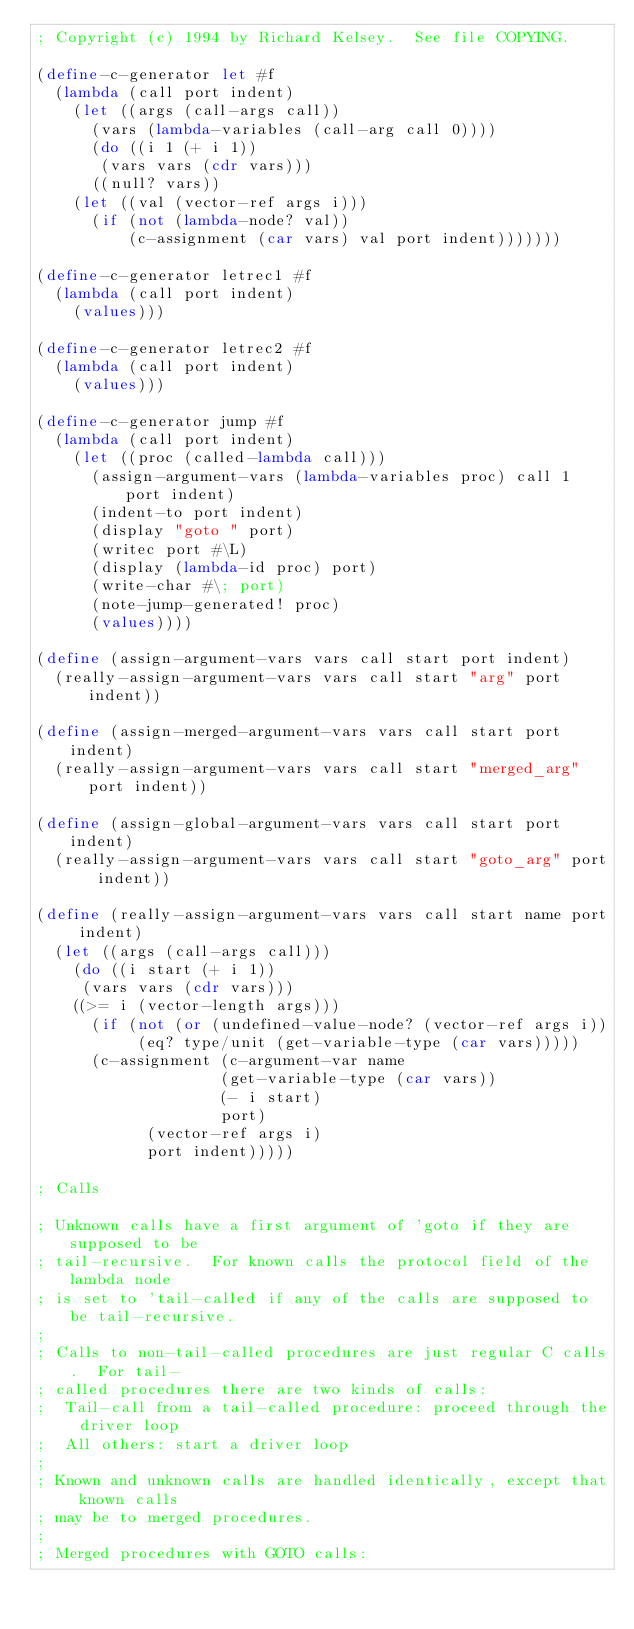Convert code to text. <code><loc_0><loc_0><loc_500><loc_500><_Scheme_>; Copyright (c) 1994 by Richard Kelsey.  See file COPYING.

(define-c-generator let #f
  (lambda (call port indent)
    (let ((args (call-args call))
	  (vars (lambda-variables (call-arg call 0))))
      (do ((i 1 (+ i 1))
	   (vars vars (cdr vars)))
	  ((null? vars))
	(let ((val (vector-ref args i)))
	  (if (not (lambda-node? val))
	      (c-assignment (car vars) val port indent)))))))

(define-c-generator letrec1 #f
  (lambda (call port indent)
    (values)))

(define-c-generator letrec2 #f
  (lambda (call port indent)
    (values)))

(define-c-generator jump #f
  (lambda (call port indent)
    (let ((proc (called-lambda call)))
      (assign-argument-vars (lambda-variables proc) call 1 port indent)
      (indent-to port indent)
      (display "goto " port)
      (writec port #\L)
      (display (lambda-id proc) port)
      (write-char #\; port)
      (note-jump-generated! proc)
      (values))))
  
(define (assign-argument-vars vars call start port indent)
  (really-assign-argument-vars vars call start "arg" port indent))

(define (assign-merged-argument-vars vars call start port indent)
  (really-assign-argument-vars vars call start "merged_arg" port indent))

(define (assign-global-argument-vars vars call start port indent)
  (really-assign-argument-vars vars call start "goto_arg" port indent))

(define (really-assign-argument-vars vars call start name port indent)
  (let ((args (call-args call)))
    (do ((i start (+ i 1))
	 (vars vars (cdr vars)))
	((>= i (vector-length args)))
      (if (not (or (undefined-value-node? (vector-ref args i))
		   (eq? type/unit (get-variable-type (car vars)))))
	  (c-assignment (c-argument-var name
					(get-variable-type (car vars))
					(- i start)
					port)
			(vector-ref args i)
			port indent)))))

; Calls

; Unknown calls have a first argument of 'goto if they are supposed to be
; tail-recursive.  For known calls the protocol field of the lambda node
; is set to 'tail-called if any of the calls are supposed to be tail-recursive.
;
; Calls to non-tail-called procedures are just regular C calls.  For tail-
; called procedures there are two kinds of calls:
;  Tail-call from a tail-called procedure: proceed through the driver loop
;  All others: start a driver loop
;
; Known and unknown calls are handled identically, except that known calls
; may be to merged procedures.
;
; Merged procedures with GOTO calls:</code> 